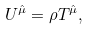<formula> <loc_0><loc_0><loc_500><loc_500>U ^ { \hat { \mu } } = \rho T ^ { \hat { \mu } } ,</formula> 